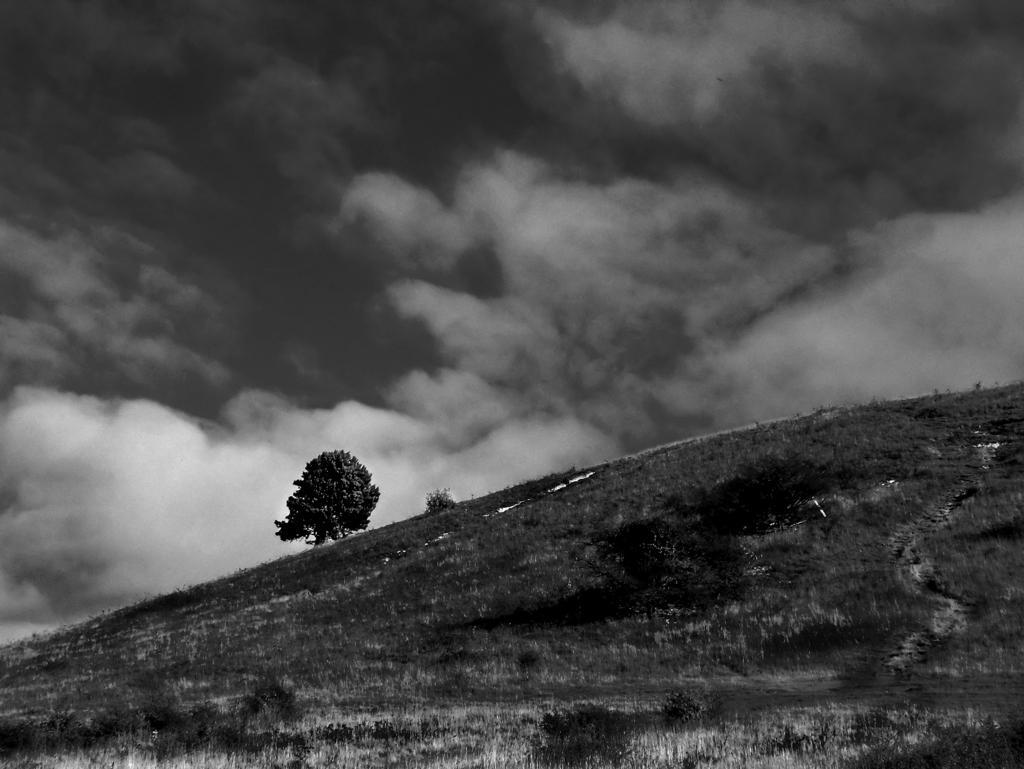How would you summarize this image in a sentence or two? This is a black and white image, in this image there is grass and a tree, at the top of the image there are clouds in the sky. 